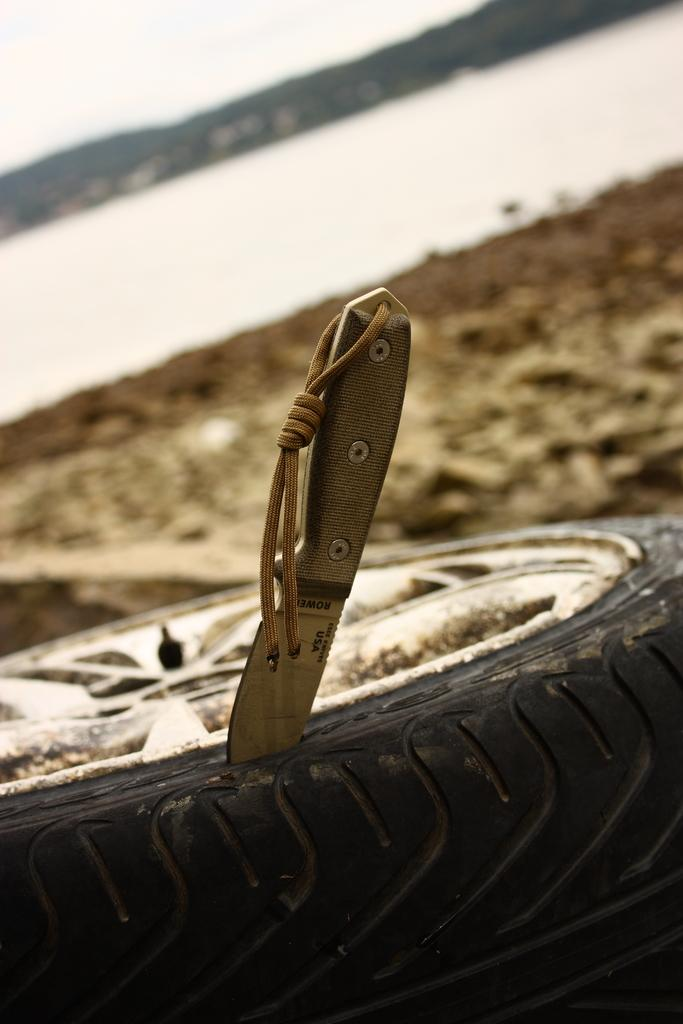What objects are located at the bottom of the image? There is a wheel and a knife at the bottom of the image. What can be seen in the background of the image? The ground is visible in the background of the image. What is visible at the top of the image? The sky is visible at the top of the image. How would you describe the appearance of the background? The background appears blurred. What type of tin can be seen in the image? There is no tin present in the image. What hobbies are the people in the image engaged in? There are no people present in the image, so their hobbies cannot be determined. 